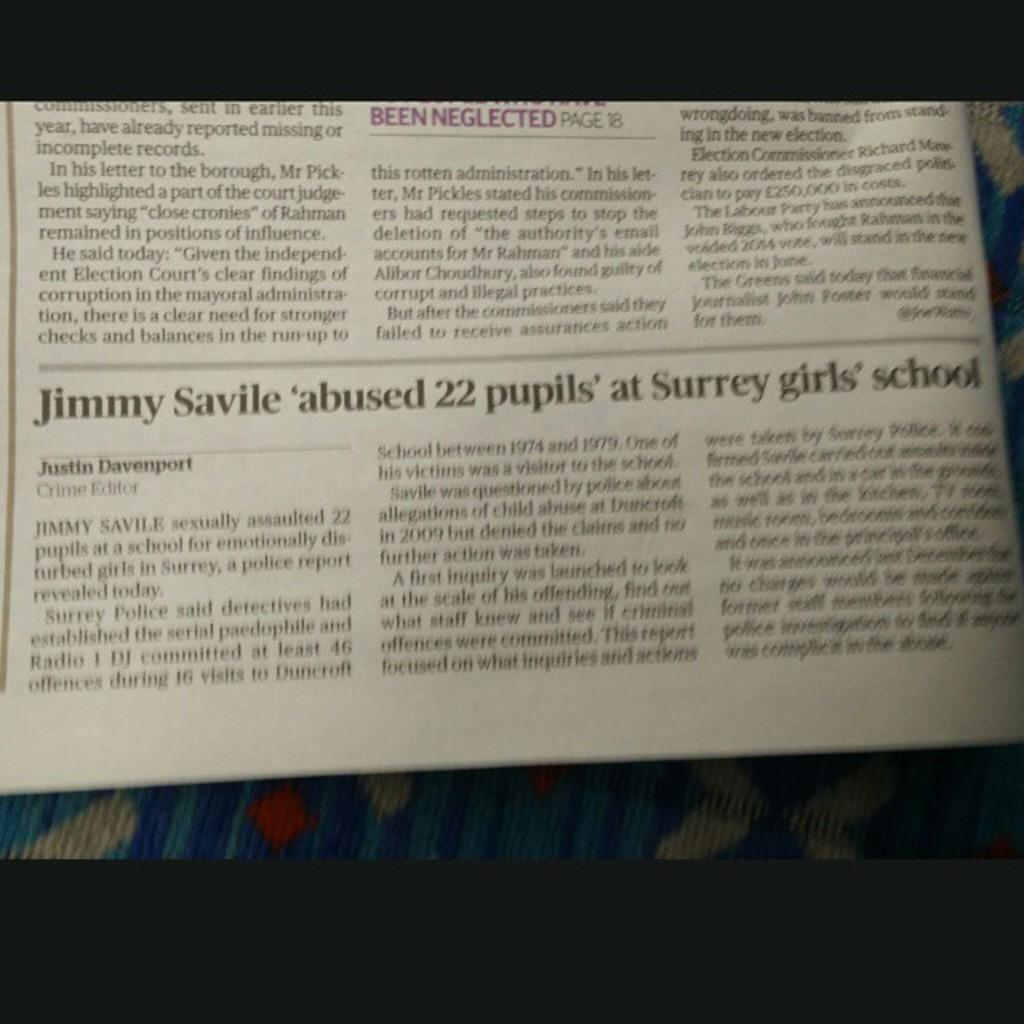<image>
Write a terse but informative summary of the picture. A newspaper clipping of an article about Jimmy Savile. 